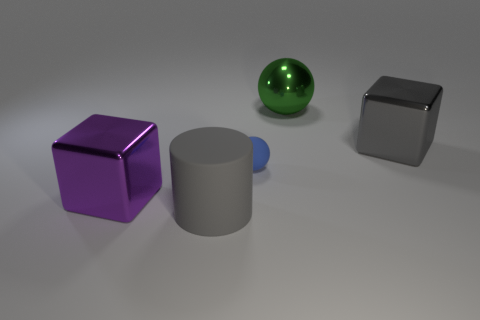Add 4 small blue objects. How many objects exist? 9 Subtract all cylinders. How many objects are left? 4 Subtract all large brown matte cubes. Subtract all gray shiny objects. How many objects are left? 4 Add 5 large gray cylinders. How many large gray cylinders are left? 6 Add 1 large gray objects. How many large gray objects exist? 3 Subtract 0 blue blocks. How many objects are left? 5 